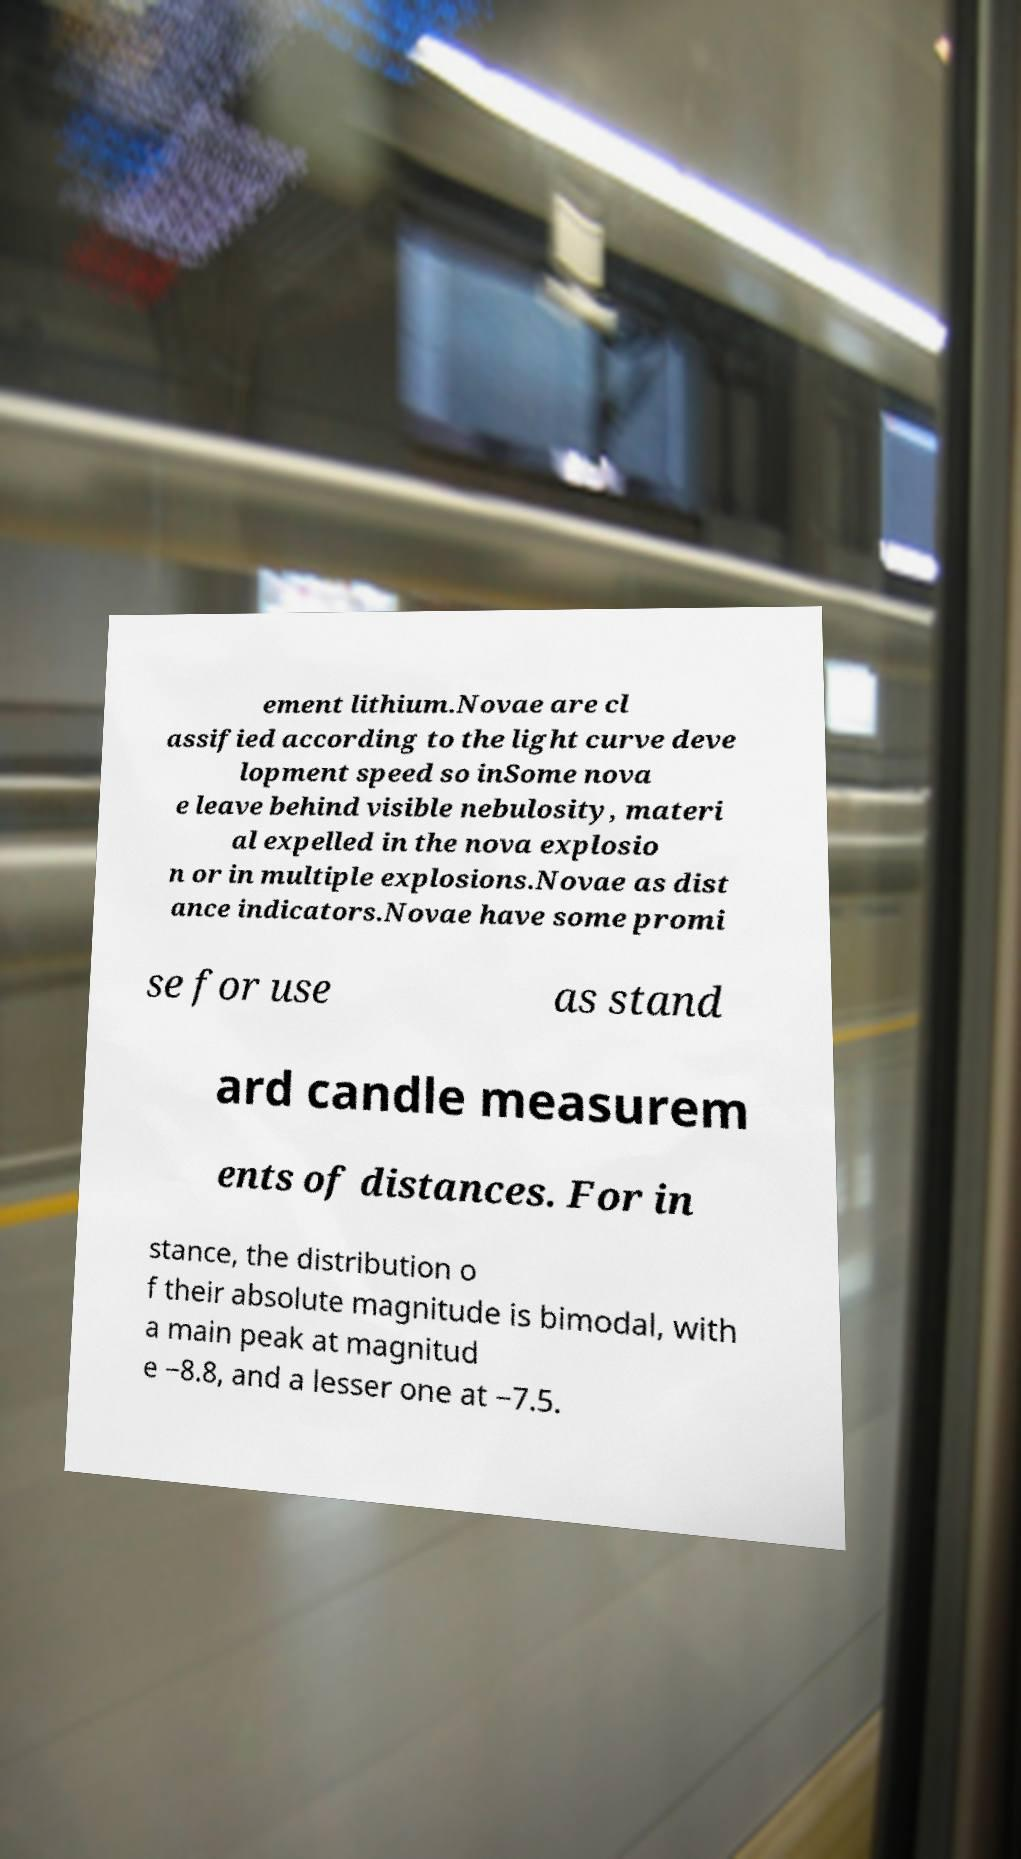For documentation purposes, I need the text within this image transcribed. Could you provide that? ement lithium.Novae are cl assified according to the light curve deve lopment speed so inSome nova e leave behind visible nebulosity, materi al expelled in the nova explosio n or in multiple explosions.Novae as dist ance indicators.Novae have some promi se for use as stand ard candle measurem ents of distances. For in stance, the distribution o f their absolute magnitude is bimodal, with a main peak at magnitud e −8.8, and a lesser one at −7.5. 